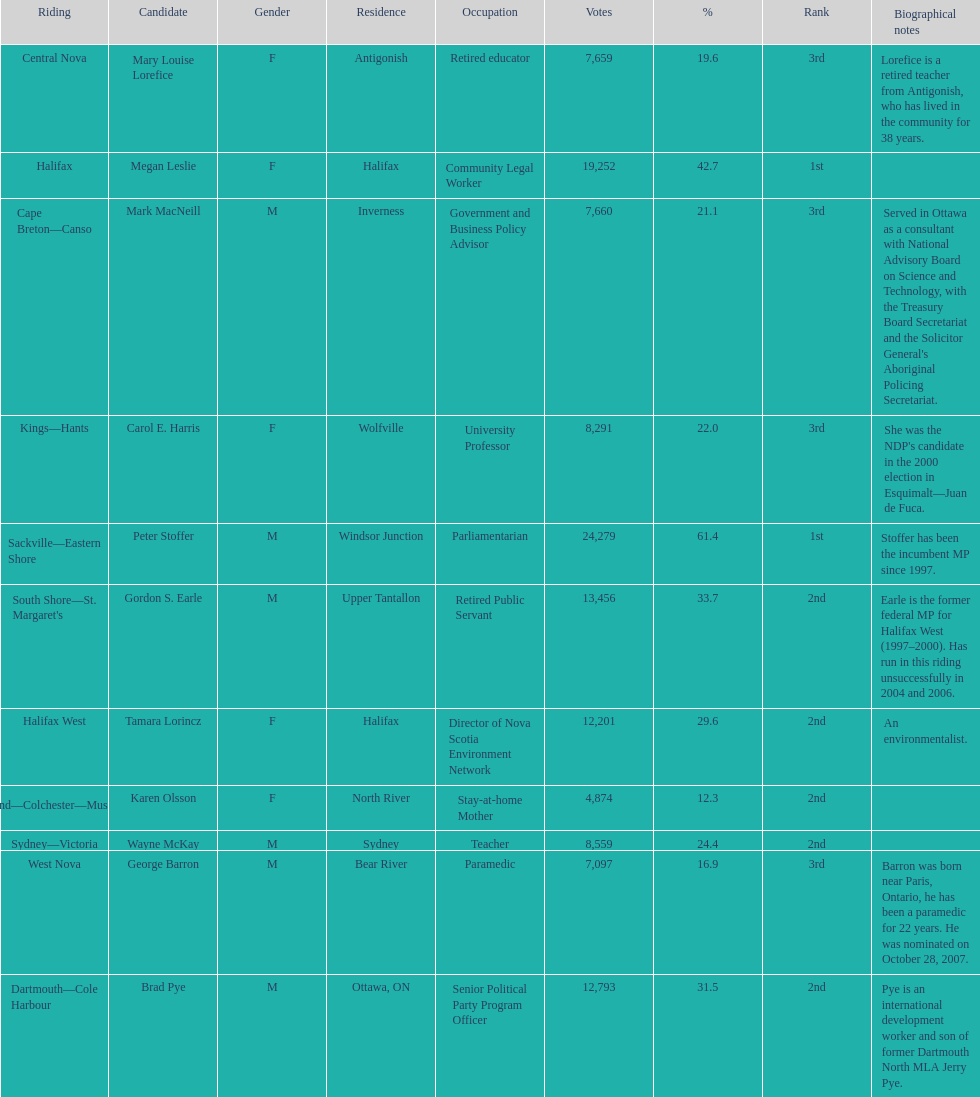Who are all the candidates? Mark MacNeill, Mary Louise Lorefice, Karen Olsson, Brad Pye, Megan Leslie, Tamara Lorincz, Carol E. Harris, Peter Stoffer, Gordon S. Earle, Wayne McKay, George Barron. How many votes did they receive? 7,660, 7,659, 4,874, 12,793, 19,252, 12,201, 8,291, 24,279, 13,456, 8,559, 7,097. And of those, how many were for megan leslie? 19,252. 